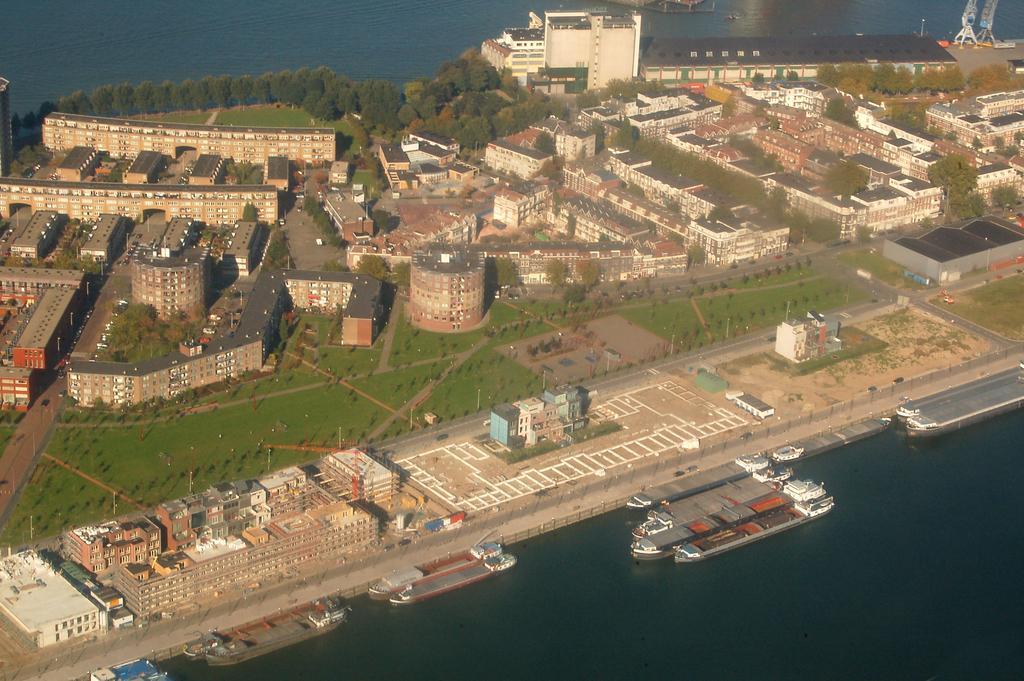Please provide a concise description of this image. In this image I can see at the bottom there is water, there are ships in it. In the middle there are trees and buildings, it looks like a miniature. 